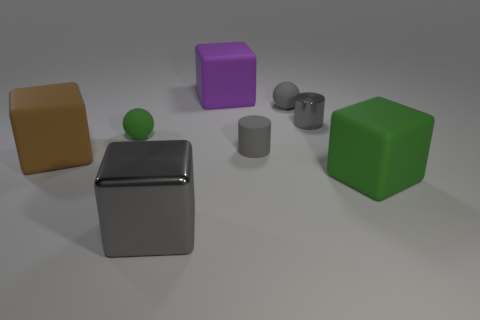Subtract 2 cubes. How many cubes are left? 2 Subtract all rubber blocks. How many blocks are left? 1 Subtract all purple blocks. How many blocks are left? 3 Add 1 blue cylinders. How many objects exist? 9 Subtract all yellow cubes. Subtract all yellow spheres. How many cubes are left? 4 Subtract all cylinders. How many objects are left? 6 Add 5 red balls. How many red balls exist? 5 Subtract 0 cyan blocks. How many objects are left? 8 Subtract all small gray shiny objects. Subtract all shiny objects. How many objects are left? 5 Add 3 spheres. How many spheres are left? 5 